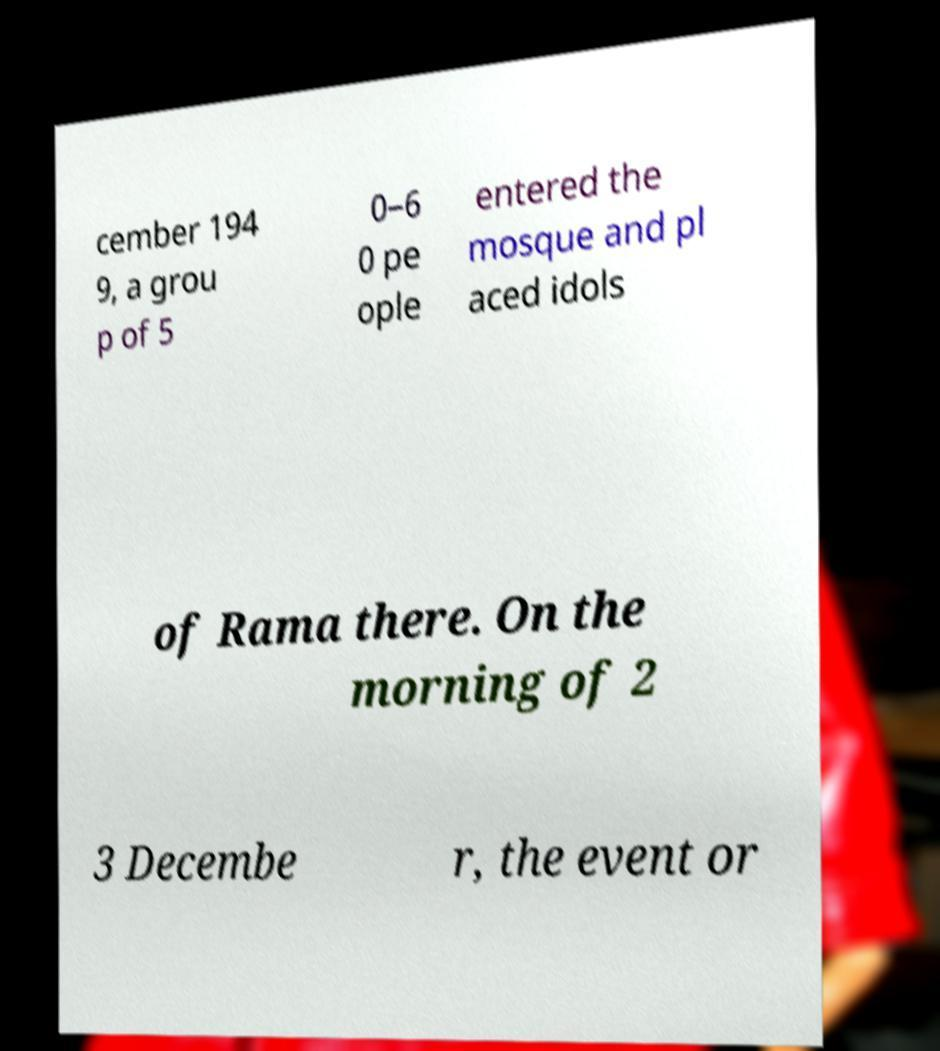For documentation purposes, I need the text within this image transcribed. Could you provide that? cember 194 9, a grou p of 5 0–6 0 pe ople entered the mosque and pl aced idols of Rama there. On the morning of 2 3 Decembe r, the event or 